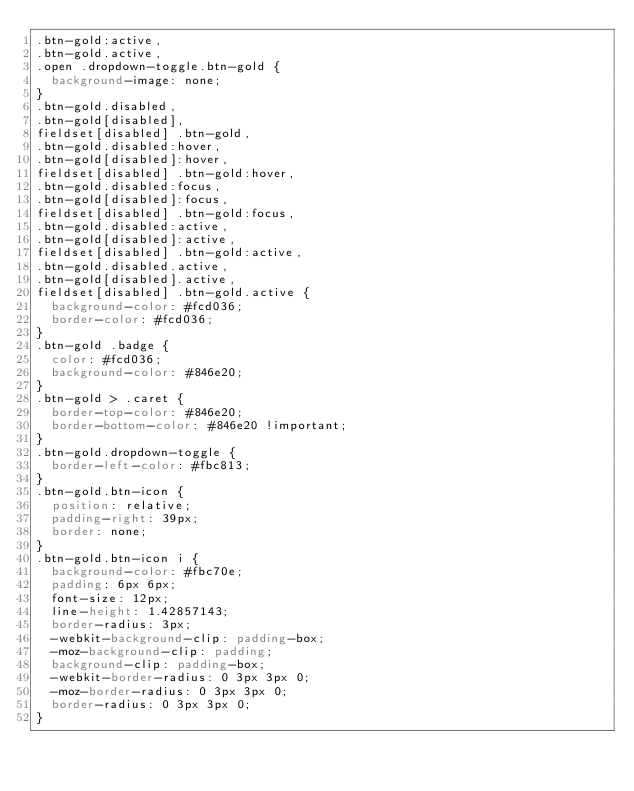<code> <loc_0><loc_0><loc_500><loc_500><_CSS_>.btn-gold:active,
.btn-gold.active,
.open .dropdown-toggle.btn-gold {
  background-image: none;
}
.btn-gold.disabled,
.btn-gold[disabled],
fieldset[disabled] .btn-gold,
.btn-gold.disabled:hover,
.btn-gold[disabled]:hover,
fieldset[disabled] .btn-gold:hover,
.btn-gold.disabled:focus,
.btn-gold[disabled]:focus,
fieldset[disabled] .btn-gold:focus,
.btn-gold.disabled:active,
.btn-gold[disabled]:active,
fieldset[disabled] .btn-gold:active,
.btn-gold.disabled.active,
.btn-gold[disabled].active,
fieldset[disabled] .btn-gold.active {
  background-color: #fcd036;
  border-color: #fcd036;
}
.btn-gold .badge {
  color: #fcd036;
  background-color: #846e20;
}
.btn-gold > .caret {
  border-top-color: #846e20;
  border-bottom-color: #846e20 !important;
}
.btn-gold.dropdown-toggle {
  border-left-color: #fbc813;
}
.btn-gold.btn-icon {
  position: relative;
  padding-right: 39px;
  border: none;
}
.btn-gold.btn-icon i {
  background-color: #fbc70e;
  padding: 6px 6px;
  font-size: 12px;
  line-height: 1.42857143;
  border-radius: 3px;
  -webkit-background-clip: padding-box;
  -moz-background-clip: padding;
  background-clip: padding-box;
  -webkit-border-radius: 0 3px 3px 0;
  -moz-border-radius: 0 3px 3px 0;
  border-radius: 0 3px 3px 0;
}</code> 